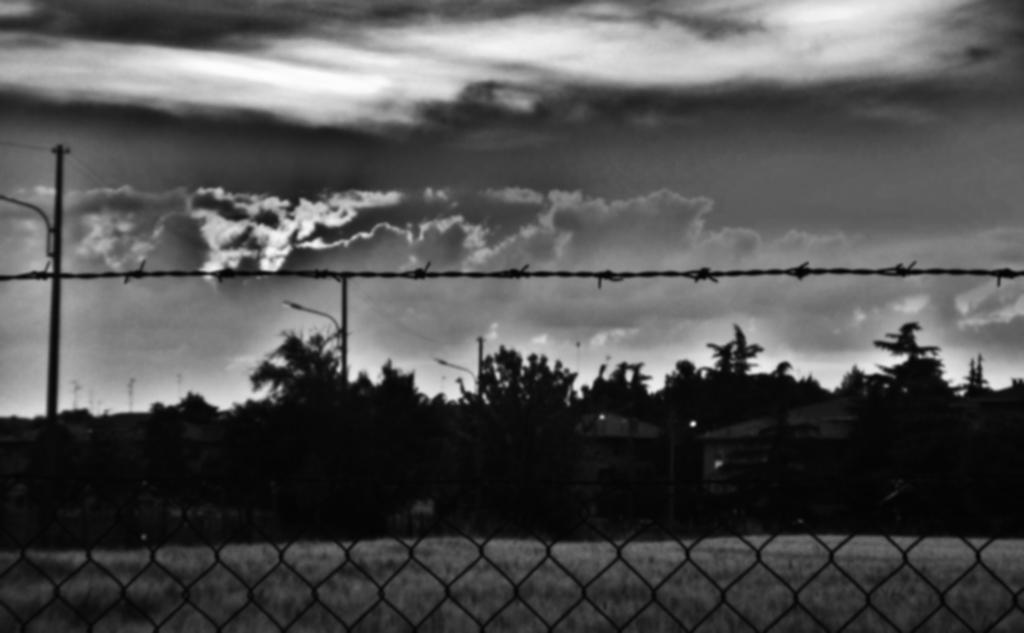Could you give a brief overview of what you see in this image? In the foreground there is fencing. In the middle there are trees, pole and cables. In the background there is sky. 